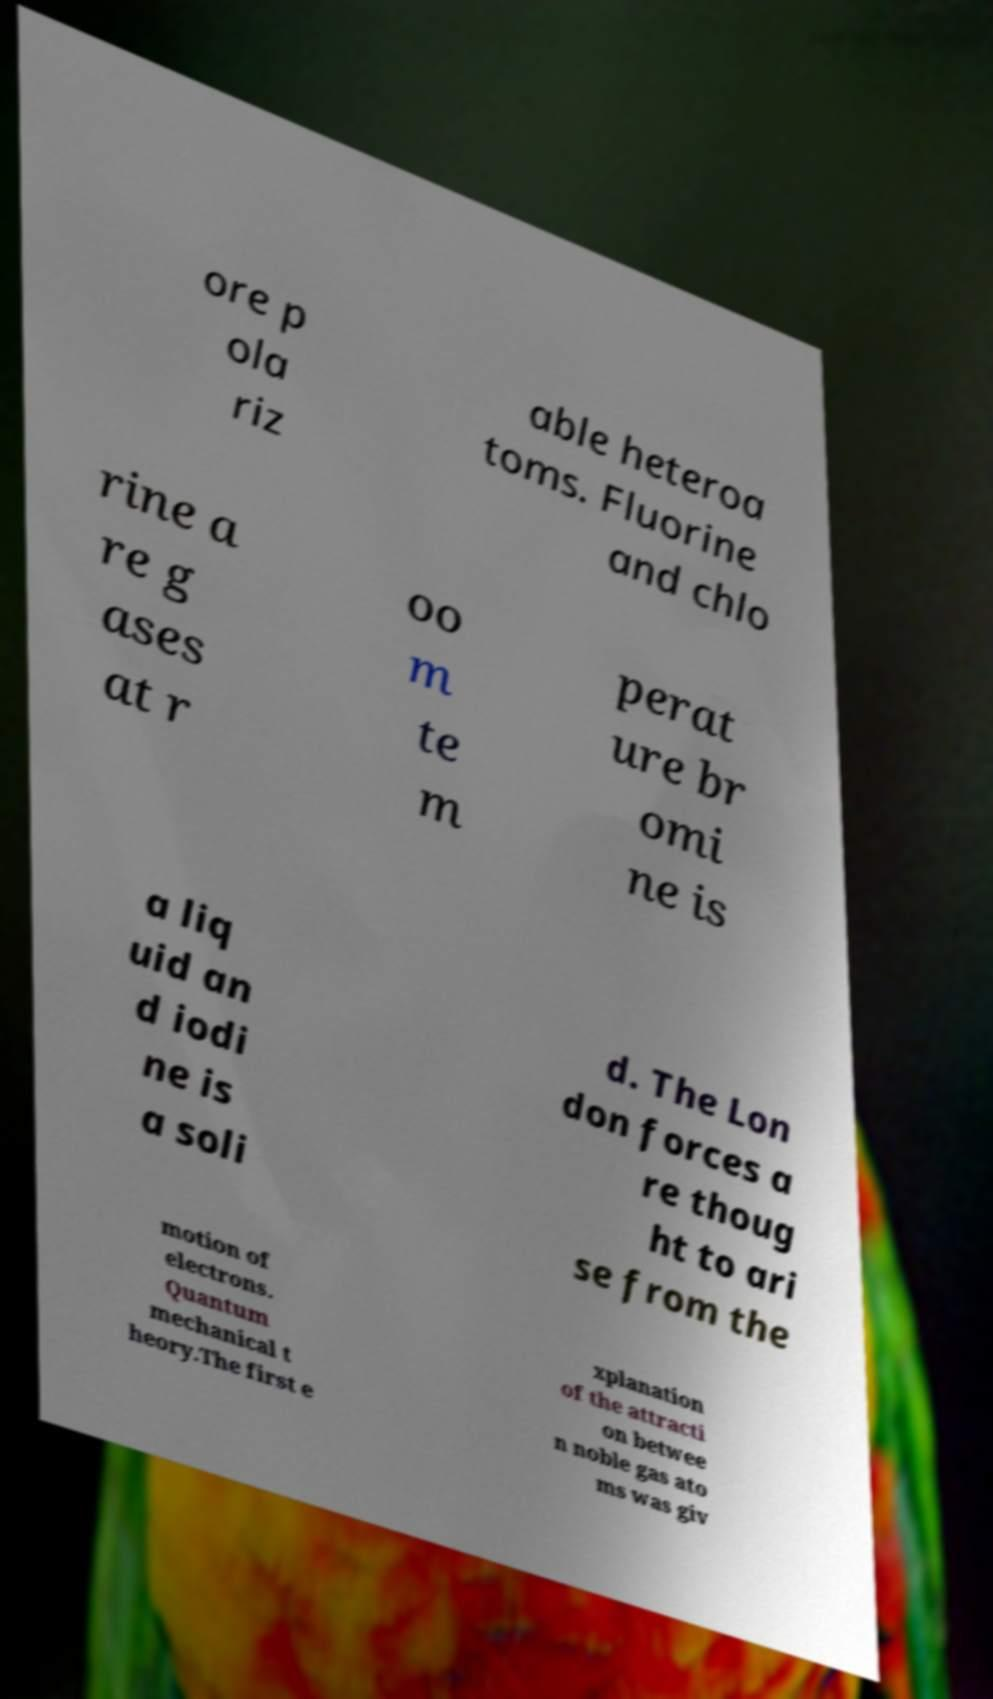Please read and relay the text visible in this image. What does it say? ore p ola riz able heteroa toms. Fluorine and chlo rine a re g ases at r oo m te m perat ure br omi ne is a liq uid an d iodi ne is a soli d. The Lon don forces a re thoug ht to ari se from the motion of electrons. Quantum mechanical t heory.The first e xplanation of the attracti on betwee n noble gas ato ms was giv 